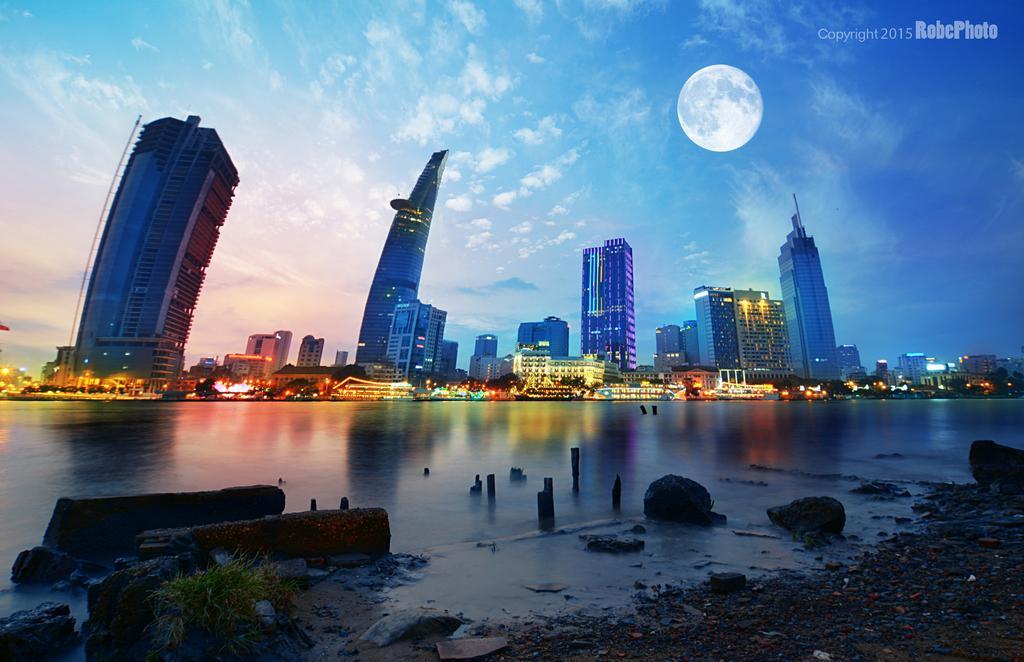Could you give a brief overview of what you see in this image? In the picture we can see water near it, we can see some stone surface and some grass and far away from it, we can see houses with lights and behind it, we can see some tower buildings with many floors and behind it we can see a sky with clouds and moon. 